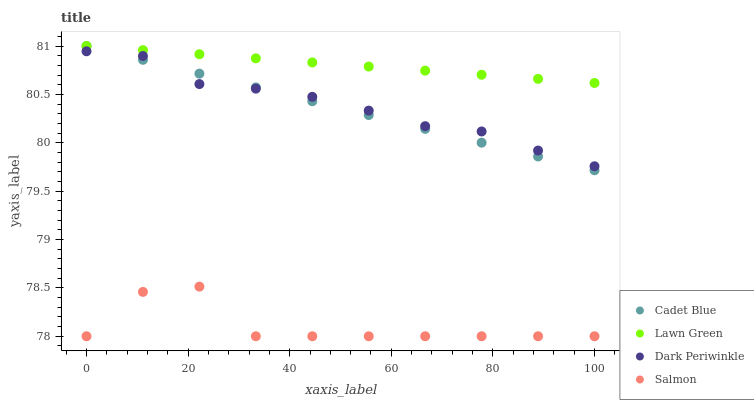Does Salmon have the minimum area under the curve?
Answer yes or no. Yes. Does Lawn Green have the maximum area under the curve?
Answer yes or no. Yes. Does Cadet Blue have the minimum area under the curve?
Answer yes or no. No. Does Cadet Blue have the maximum area under the curve?
Answer yes or no. No. Is Cadet Blue the smoothest?
Answer yes or no. Yes. Is Salmon the roughest?
Answer yes or no. Yes. Is Salmon the smoothest?
Answer yes or no. No. Is Cadet Blue the roughest?
Answer yes or no. No. Does Salmon have the lowest value?
Answer yes or no. Yes. Does Cadet Blue have the lowest value?
Answer yes or no. No. Does Cadet Blue have the highest value?
Answer yes or no. Yes. Does Salmon have the highest value?
Answer yes or no. No. Is Salmon less than Dark Periwinkle?
Answer yes or no. Yes. Is Lawn Green greater than Salmon?
Answer yes or no. Yes. Does Lawn Green intersect Cadet Blue?
Answer yes or no. Yes. Is Lawn Green less than Cadet Blue?
Answer yes or no. No. Is Lawn Green greater than Cadet Blue?
Answer yes or no. No. Does Salmon intersect Dark Periwinkle?
Answer yes or no. No. 